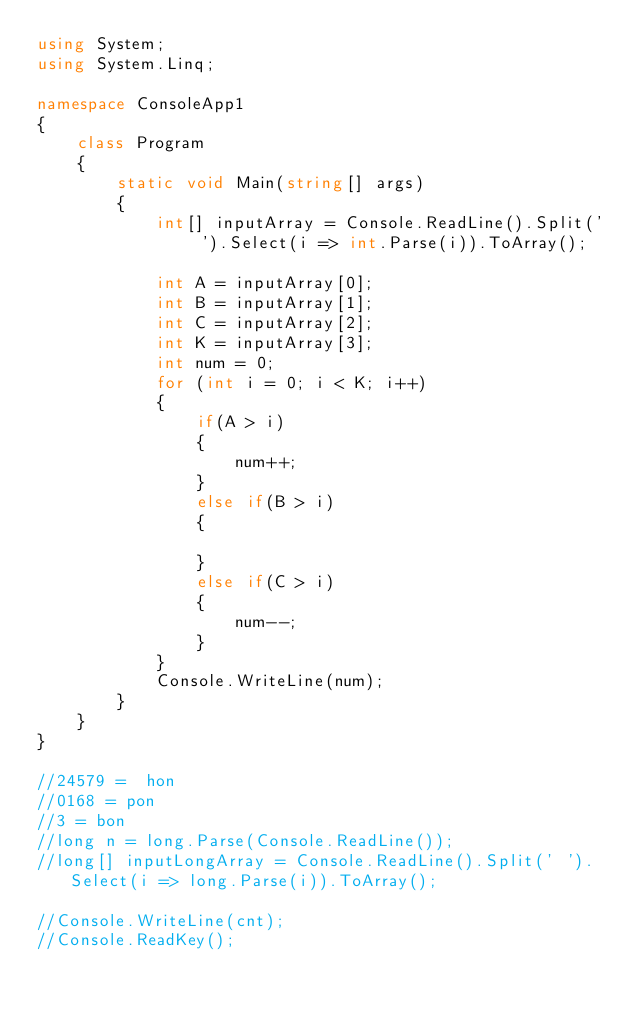<code> <loc_0><loc_0><loc_500><loc_500><_C#_>using System;
using System.Linq;

namespace ConsoleApp1
{
    class Program
    {
        static void Main(string[] args)
        {
            int[] inputArray = Console.ReadLine().Split(' ').Select(i => int.Parse(i)).ToArray();

            int A = inputArray[0];
            int B = inputArray[1];
            int C = inputArray[2];
            int K = inputArray[3];
            int num = 0;
            for (int i = 0; i < K; i++)
            {
                if(A > i)
                {
                    num++;
                }
                else if(B > i)
                {
                    
                }
                else if(C > i)
                {
                    num--;
                }
            }
            Console.WriteLine(num);
        }
    }
}

//24579 =  hon
//0168 = pon
//3 = bon
//long n = long.Parse(Console.ReadLine());
//long[] inputLongArray = Console.ReadLine().Split(' ').Select(i => long.Parse(i)).ToArray();

//Console.WriteLine(cnt);
//Console.ReadKey();
</code> 